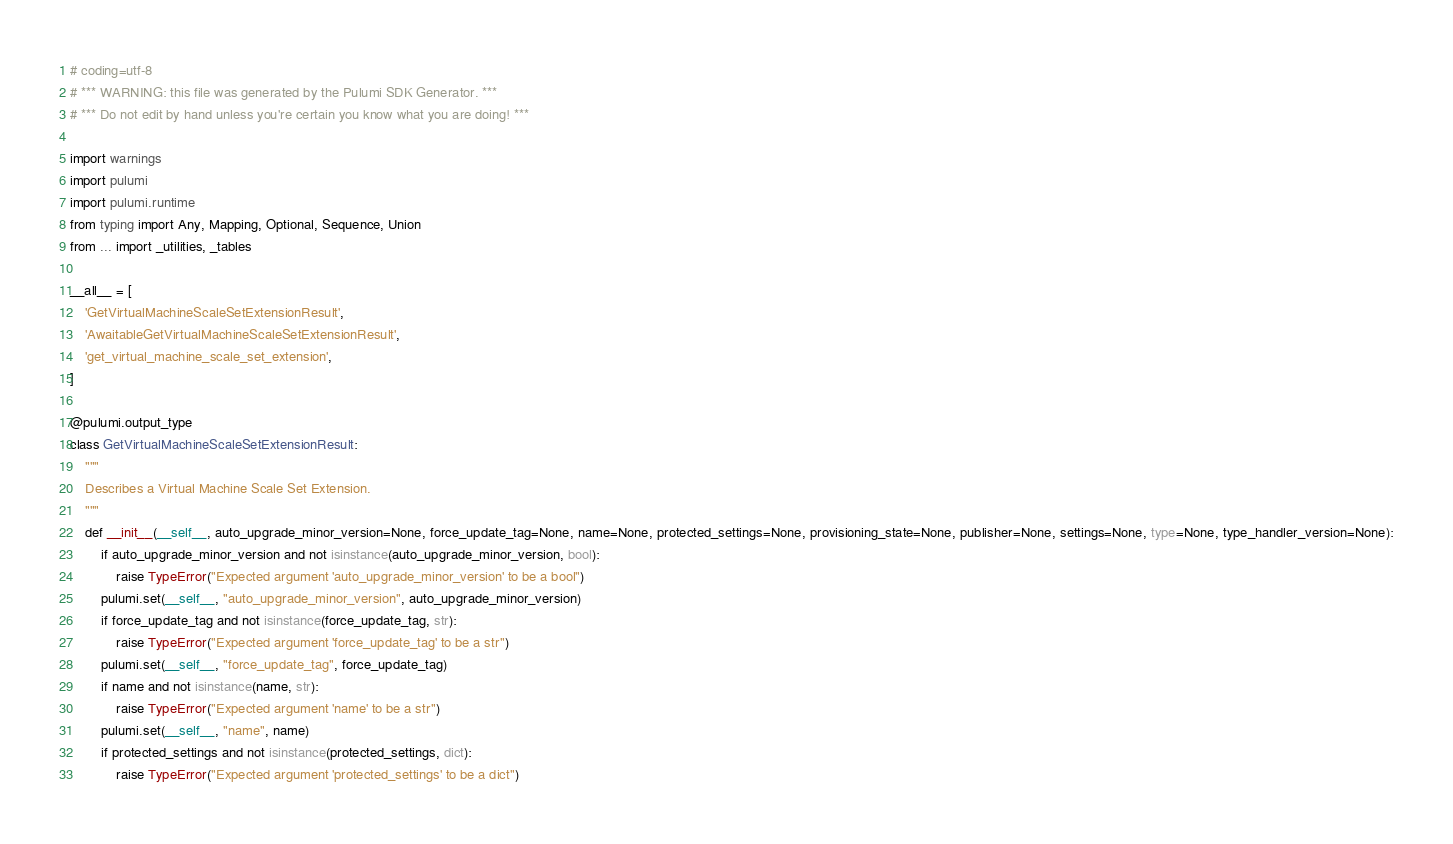<code> <loc_0><loc_0><loc_500><loc_500><_Python_># coding=utf-8
# *** WARNING: this file was generated by the Pulumi SDK Generator. ***
# *** Do not edit by hand unless you're certain you know what you are doing! ***

import warnings
import pulumi
import pulumi.runtime
from typing import Any, Mapping, Optional, Sequence, Union
from ... import _utilities, _tables

__all__ = [
    'GetVirtualMachineScaleSetExtensionResult',
    'AwaitableGetVirtualMachineScaleSetExtensionResult',
    'get_virtual_machine_scale_set_extension',
]

@pulumi.output_type
class GetVirtualMachineScaleSetExtensionResult:
    """
    Describes a Virtual Machine Scale Set Extension.
    """
    def __init__(__self__, auto_upgrade_minor_version=None, force_update_tag=None, name=None, protected_settings=None, provisioning_state=None, publisher=None, settings=None, type=None, type_handler_version=None):
        if auto_upgrade_minor_version and not isinstance(auto_upgrade_minor_version, bool):
            raise TypeError("Expected argument 'auto_upgrade_minor_version' to be a bool")
        pulumi.set(__self__, "auto_upgrade_minor_version", auto_upgrade_minor_version)
        if force_update_tag and not isinstance(force_update_tag, str):
            raise TypeError("Expected argument 'force_update_tag' to be a str")
        pulumi.set(__self__, "force_update_tag", force_update_tag)
        if name and not isinstance(name, str):
            raise TypeError("Expected argument 'name' to be a str")
        pulumi.set(__self__, "name", name)
        if protected_settings and not isinstance(protected_settings, dict):
            raise TypeError("Expected argument 'protected_settings' to be a dict")</code> 